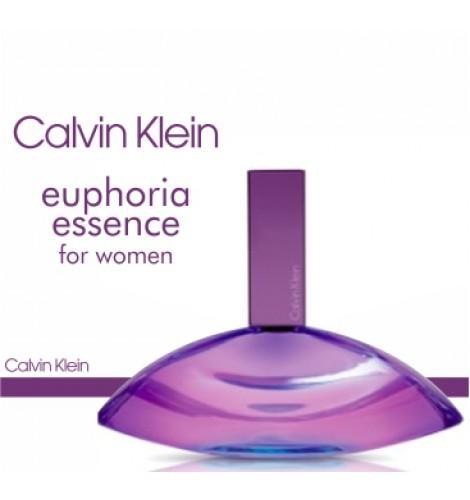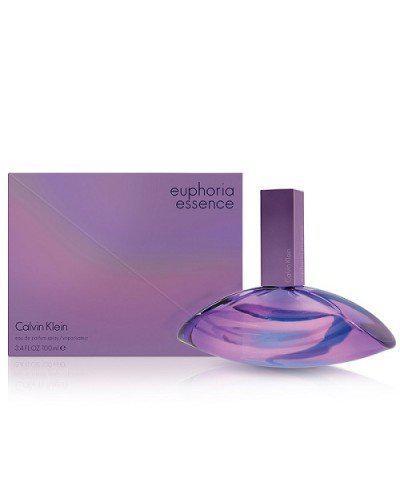The first image is the image on the left, the second image is the image on the right. For the images displayed, is the sentence "There is a box beside the bottle in one of the images." factually correct? Answer yes or no. Yes. 